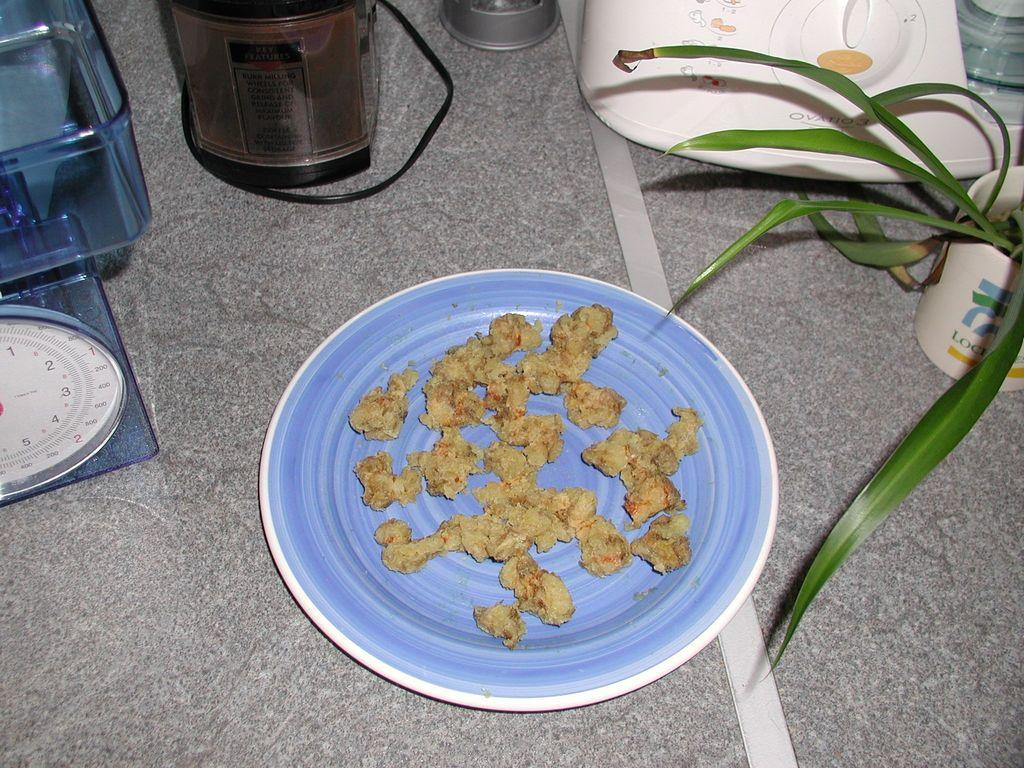What kitchen appliance can be seen in the image? There is a mixer in the image. What is on the plate that is visible in the image? There is a plate with a food item in the image. What else can be seen on the floor in the image? There are other objects placed on the floor in the image. What type of plant is present in the image? There appears to be a plant with leaves in the image. What type of blade is being used to read the news in the image? There is no blade or news present in the image; it features a mixer, a plate with a food item, objects on the floor, and a plant with leaves. 